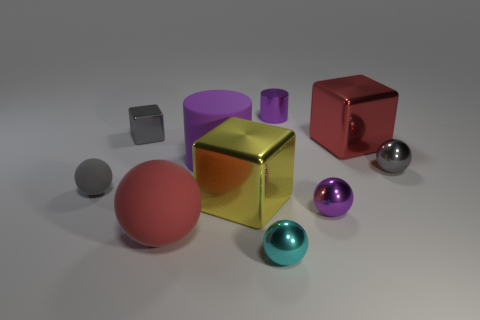What material is the tiny sphere that is the same color as the big rubber cylinder?
Give a very brief answer. Metal. What size is the metal thing that is the same color as the tiny metal cylinder?
Your answer should be compact. Small. There is another matte object that is the same shape as the big red rubber object; what is its size?
Offer a very short reply. Small. Are there any other things that are made of the same material as the tiny cyan sphere?
Ensure brevity in your answer.  Yes. There is a large object that is right of the small cyan metal ball; is its color the same as the tiny sphere that is left of the large yellow metallic object?
Offer a terse response. No. There is a red thing behind the large red thing that is in front of the large metal cube on the left side of the small purple cylinder; what is its material?
Ensure brevity in your answer.  Metal. Are there more tiny purple balls than tiny blue balls?
Offer a terse response. Yes. Is there anything else that has the same color as the large rubber cylinder?
Offer a terse response. Yes. There is a red cube that is the same material as the cyan ball; what is its size?
Your response must be concise. Large. What is the small cyan ball made of?
Your answer should be very brief. Metal. 